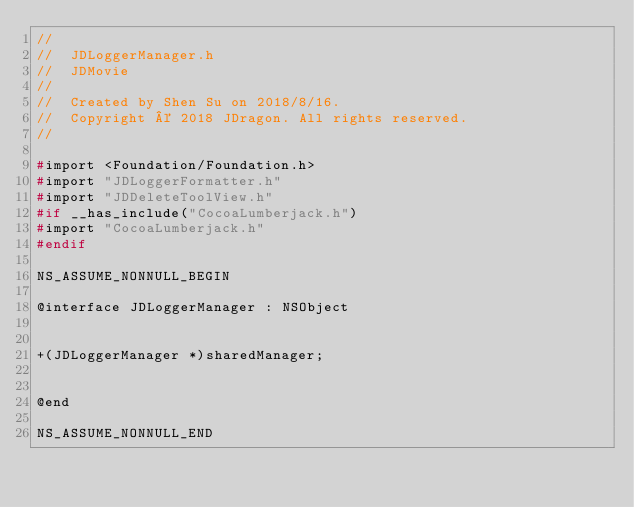Convert code to text. <code><loc_0><loc_0><loc_500><loc_500><_C_>//
//  JDLoggerManager.h
//  JDMovie
//
//  Created by Shen Su on 2018/8/16.
//  Copyright © 2018 JDragon. All rights reserved.
//

#import <Foundation/Foundation.h>
#import "JDLoggerFormatter.h"
#import "JDDeleteToolView.h"
#if __has_include("CocoaLumberjack.h")
#import "CocoaLumberjack.h"
#endif

NS_ASSUME_NONNULL_BEGIN

@interface JDLoggerManager : NSObject


+(JDLoggerManager *)sharedManager;


@end

NS_ASSUME_NONNULL_END
</code> 